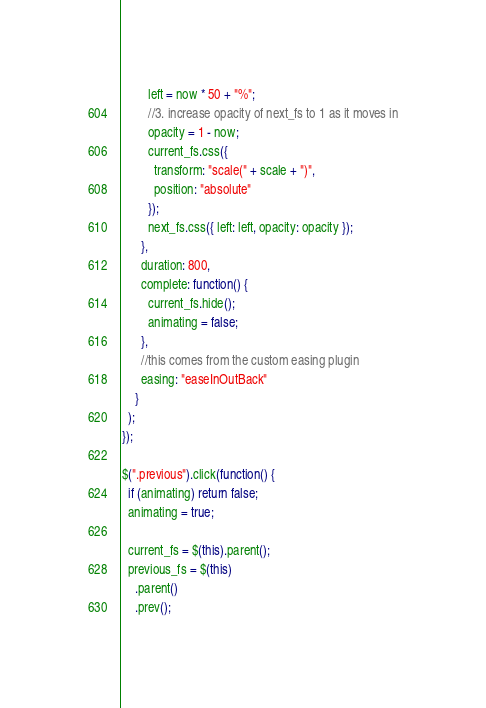<code> <loc_0><loc_0><loc_500><loc_500><_JavaScript_>        left = now * 50 + "%";
        //3. increase opacity of next_fs to 1 as it moves in
        opacity = 1 - now;
        current_fs.css({
          transform: "scale(" + scale + ")",
          position: "absolute"
        });
        next_fs.css({ left: left, opacity: opacity });
      },
      duration: 800,
      complete: function() {
        current_fs.hide();
        animating = false;
      },
      //this comes from the custom easing plugin
      easing: "easeInOutBack"
    }
  );
});

$(".previous").click(function() {
  if (animating) return false;
  animating = true;

  current_fs = $(this).parent();
  previous_fs = $(this)
    .parent()
    .prev();
</code> 